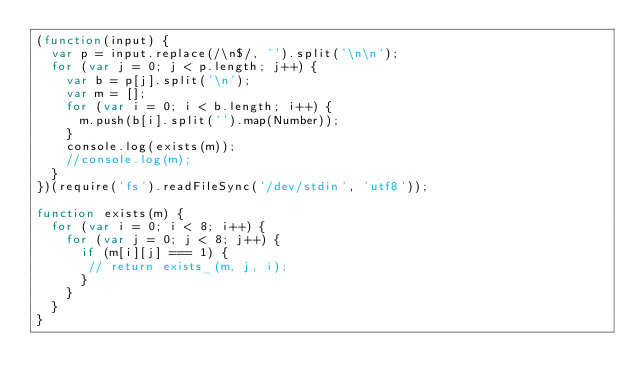<code> <loc_0><loc_0><loc_500><loc_500><_JavaScript_>(function(input) {
  var p = input.replace(/\n$/, '').split('\n\n');
  for (var j = 0; j < p.length; j++) {
    var b = p[j].split('\n');
    var m = [];
    for (var i = 0; i < b.length; i++) {
      m.push(b[i].split('').map(Number));
    }
    console.log(exists(m));
    //console.log(m);
  }
})(require('fs').readFileSync('/dev/stdin', 'utf8'));

function exists(m) {
  for (var i = 0; i < 8; i++) {
    for (var j = 0; j < 8; j++) {
      if (m[i][j] === 1) {
       // return exists_(m, j, i);
      }
    }
  }
}</code> 